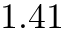Convert formula to latex. <formula><loc_0><loc_0><loc_500><loc_500>1 . 4 1</formula> 